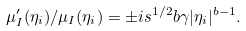Convert formula to latex. <formula><loc_0><loc_0><loc_500><loc_500>\mu _ { I } ^ { \prime } ( \eta _ { i } ) / \mu _ { I } ( \eta _ { i } ) = \pm i s ^ { 1 / 2 } b \gamma | \eta _ { i } | ^ { b - 1 } .</formula> 